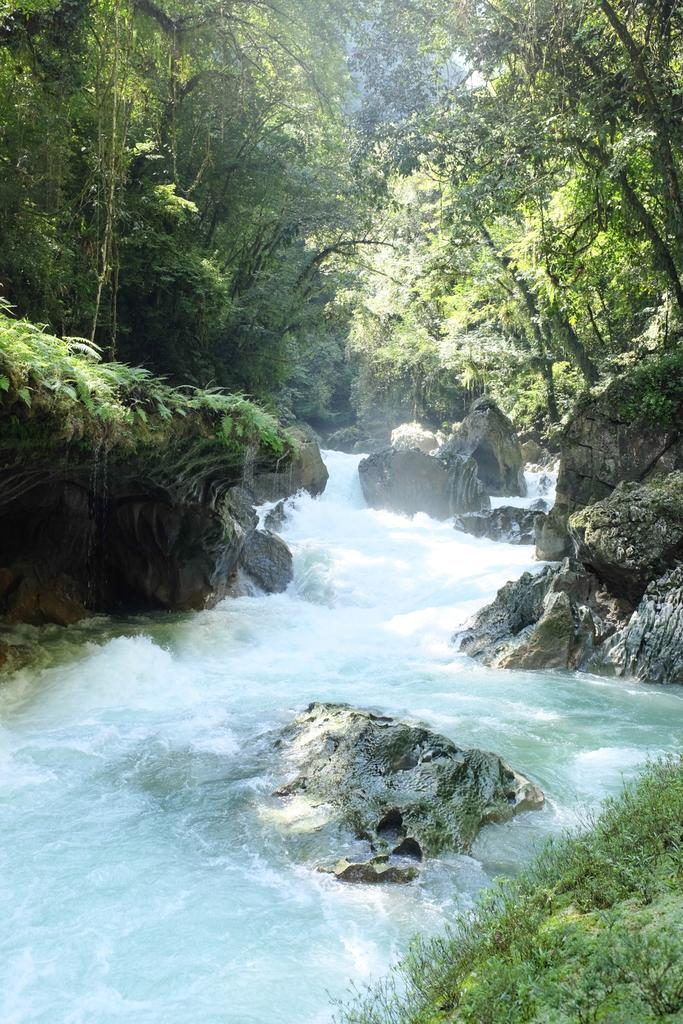What is the main feature in the center of the image? There is water in the center of the image. What type of vegetation is present on both sides of the water? There are trees on both sides of the water. Where can grass be found in the image? Grass can be found in the bottom left corner of the image. What color are the frogs that are hopping in the water? There are no frogs present in the image, so we cannot determine their color. 